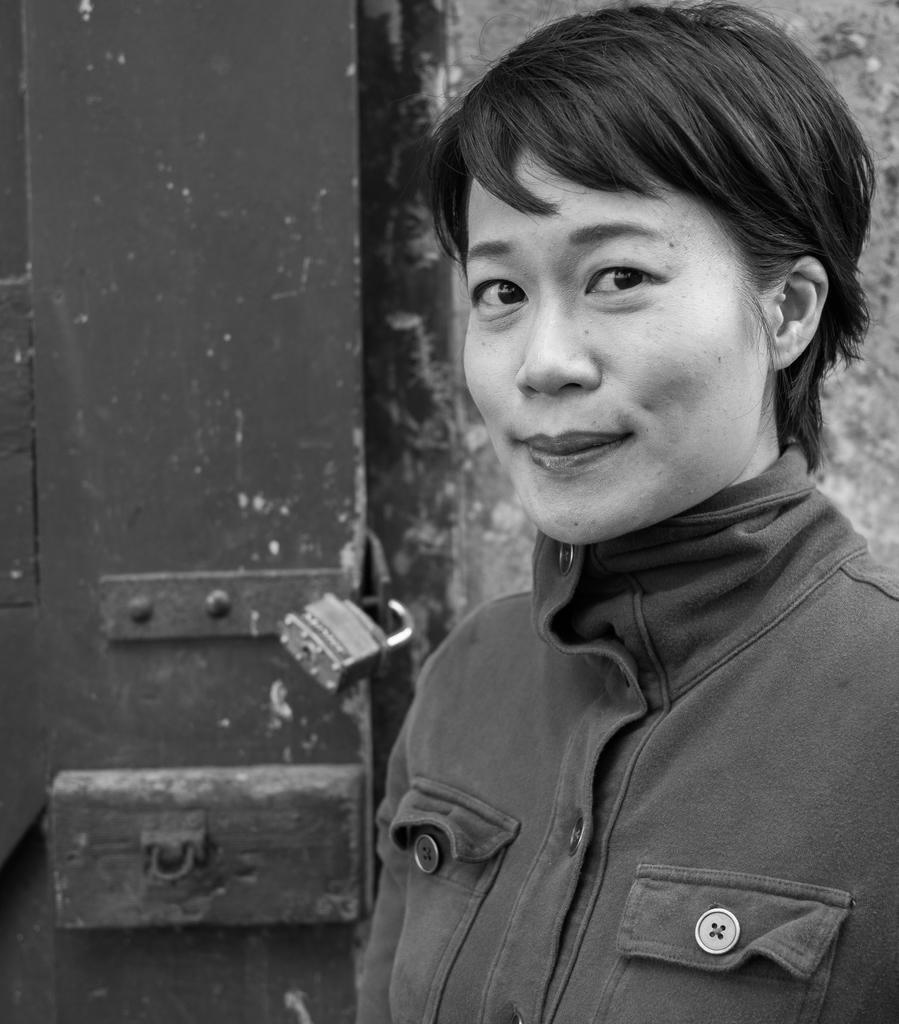Can you describe this image briefly? In this image we can see a lady is standing and she is wearing jacket, behind her door is there and lock is present on the door. 